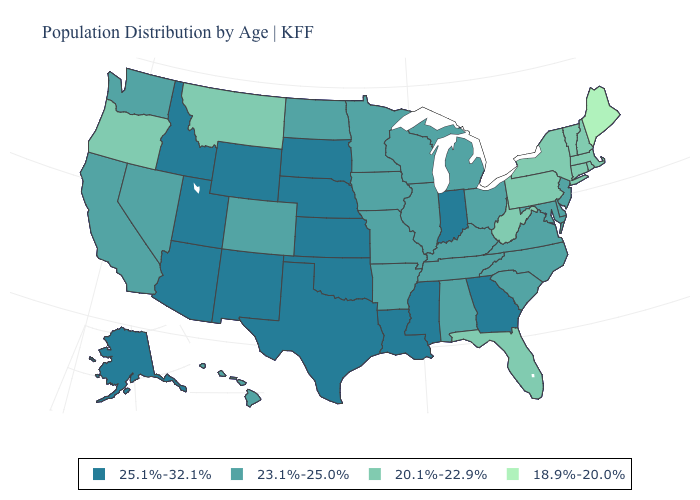Does the first symbol in the legend represent the smallest category?
Keep it brief. No. What is the value of South Carolina?
Answer briefly. 23.1%-25.0%. Name the states that have a value in the range 25.1%-32.1%?
Keep it brief. Alaska, Arizona, Georgia, Idaho, Indiana, Kansas, Louisiana, Mississippi, Nebraska, New Mexico, Oklahoma, South Dakota, Texas, Utah, Wyoming. Which states hav the highest value in the South?
Answer briefly. Georgia, Louisiana, Mississippi, Oklahoma, Texas. What is the lowest value in the Northeast?
Write a very short answer. 18.9%-20.0%. Which states have the highest value in the USA?
Keep it brief. Alaska, Arizona, Georgia, Idaho, Indiana, Kansas, Louisiana, Mississippi, Nebraska, New Mexico, Oklahoma, South Dakota, Texas, Utah, Wyoming. Does Illinois have the same value as New Hampshire?
Keep it brief. No. Does Tennessee have the same value as Florida?
Concise answer only. No. What is the highest value in the USA?
Answer briefly. 25.1%-32.1%. Which states have the lowest value in the USA?
Answer briefly. Maine. Does Washington have a higher value than New York?
Be succinct. Yes. What is the value of Tennessee?
Write a very short answer. 23.1%-25.0%. What is the highest value in the USA?
Short answer required. 25.1%-32.1%. What is the lowest value in the West?
Give a very brief answer. 20.1%-22.9%. What is the value of Kansas?
Quick response, please. 25.1%-32.1%. 